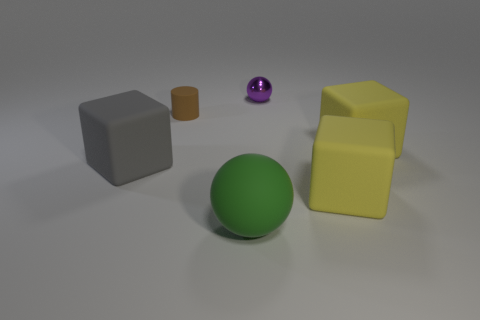What shape is the other thing that is the same size as the brown rubber thing?
Your answer should be very brief. Sphere. Are there any large matte things that have the same shape as the tiny purple thing?
Provide a short and direct response. Yes. Is the material of the big green thing the same as the big object to the left of the green rubber thing?
Keep it short and to the point. Yes. What is the cylinder that is on the left side of the ball behind the matte cylinder made of?
Offer a terse response. Rubber. Is the number of small purple metal things in front of the green matte thing greater than the number of large gray rubber spheres?
Make the answer very short. No. Is there a tiny blue object?
Your answer should be compact. No. What is the color of the ball that is in front of the small purple metallic thing?
Your answer should be very brief. Green. There is a purple thing that is the same size as the brown rubber cylinder; what material is it?
Your answer should be compact. Metal. What number of other objects are there of the same material as the big green thing?
Provide a succinct answer. 4. What color is the big rubber thing that is in front of the gray cube and to the right of the purple shiny sphere?
Make the answer very short. Yellow. 